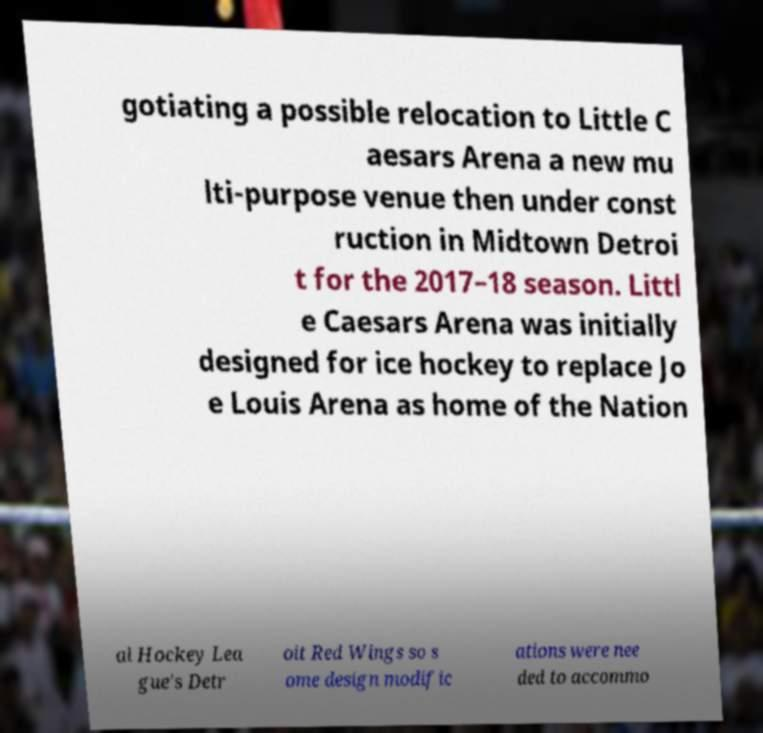Can you read and provide the text displayed in the image?This photo seems to have some interesting text. Can you extract and type it out for me? gotiating a possible relocation to Little C aesars Arena a new mu lti-purpose venue then under const ruction in Midtown Detroi t for the 2017–18 season. Littl e Caesars Arena was initially designed for ice hockey to replace Jo e Louis Arena as home of the Nation al Hockey Lea gue's Detr oit Red Wings so s ome design modific ations were nee ded to accommo 